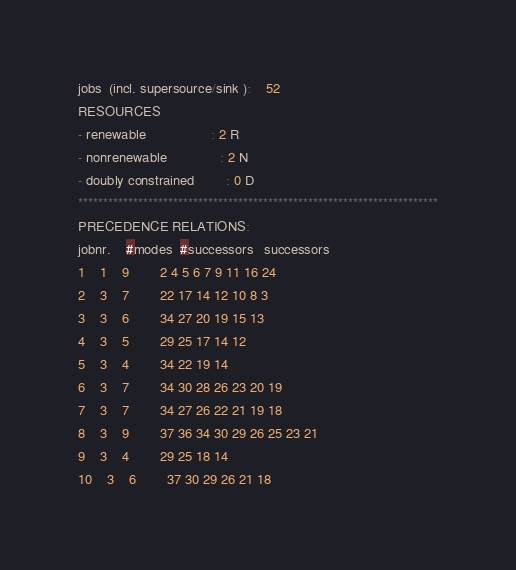Convert code to text. <code><loc_0><loc_0><loc_500><loc_500><_ObjectiveC_>jobs  (incl. supersource/sink ):	52
RESOURCES
- renewable                 : 2 R
- nonrenewable              : 2 N
- doubly constrained        : 0 D
************************************************************************
PRECEDENCE RELATIONS:
jobnr.    #modes  #successors   successors
1	1	9		2 4 5 6 7 9 11 16 24 
2	3	7		22 17 14 12 10 8 3 
3	3	6		34 27 20 19 15 13 
4	3	5		29 25 17 14 12 
5	3	4		34 22 19 14 
6	3	7		34 30 28 26 23 20 19 
7	3	7		34 27 26 22 21 19 18 
8	3	9		37 36 34 30 29 26 25 23 21 
9	3	4		29 25 18 14 
10	3	6		37 30 29 26 21 18 </code> 